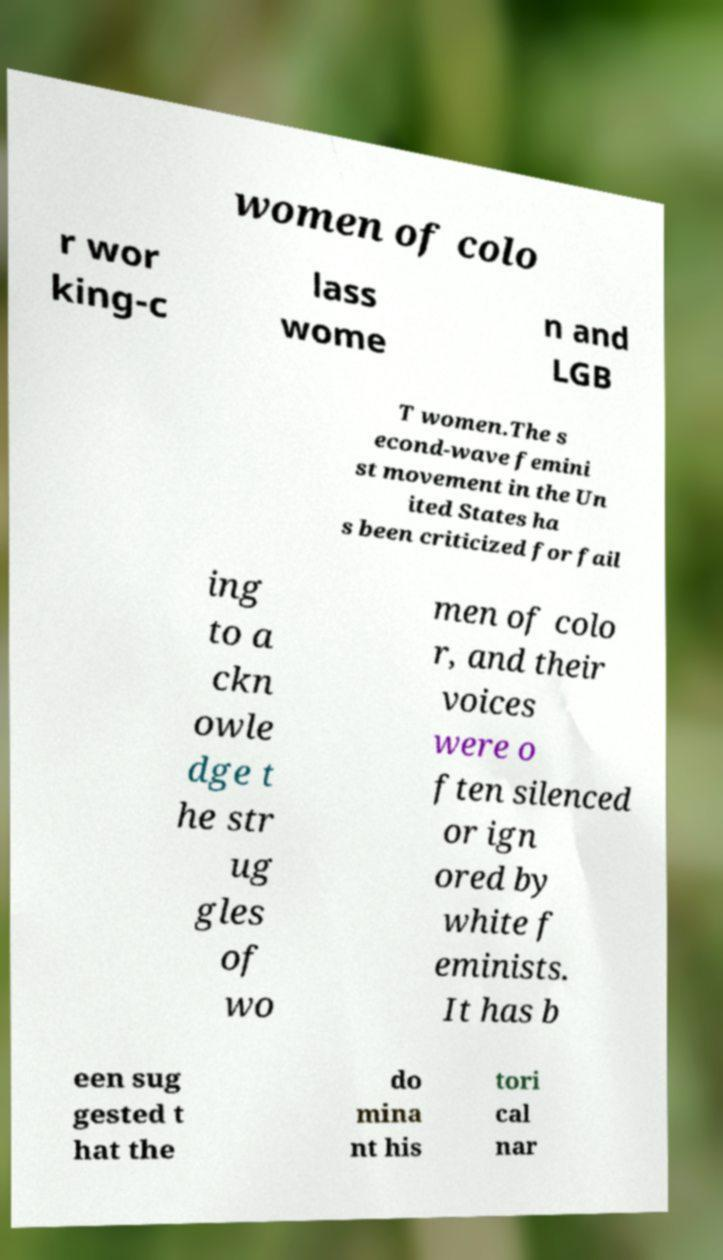Can you read and provide the text displayed in the image?This photo seems to have some interesting text. Can you extract and type it out for me? women of colo r wor king-c lass wome n and LGB T women.The s econd-wave femini st movement in the Un ited States ha s been criticized for fail ing to a ckn owle dge t he str ug gles of wo men of colo r, and their voices were o ften silenced or ign ored by white f eminists. It has b een sug gested t hat the do mina nt his tori cal nar 